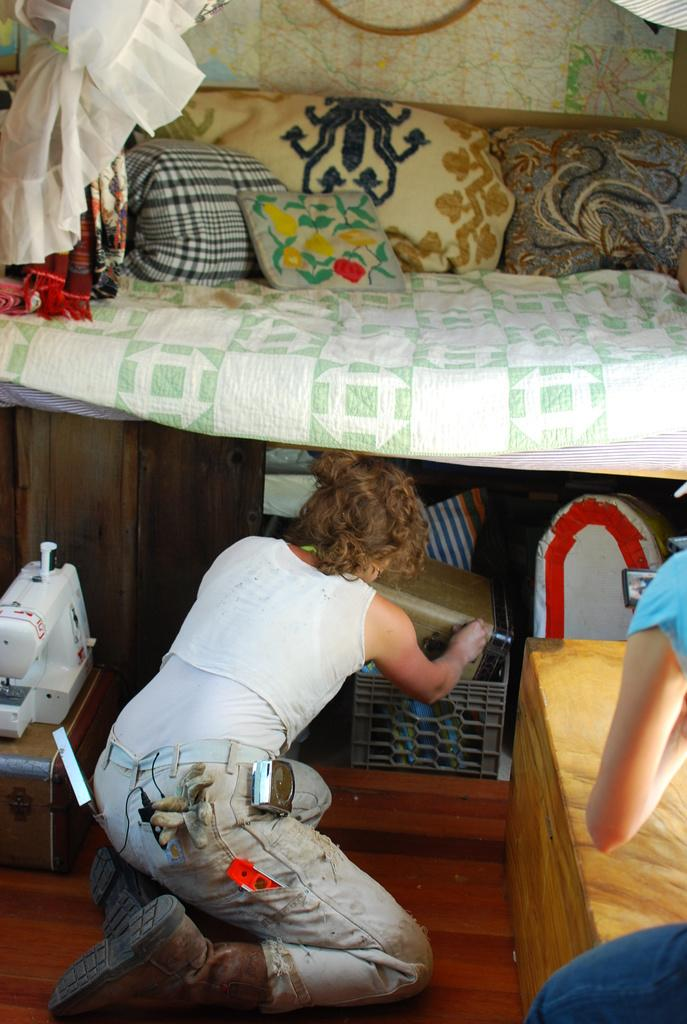How many people are present in the image? There are two people in the image. What is the surface beneath the people? There is a floor visible in the image. What type of material is used for some of the objects in the image? There are wooden objects in the image. What type of soft furnishings can be seen in the image? There are pillows in the image. What type of personal items are visible in the image? There are clothes in the image. Can you describe any unspecified objects in the image? There are unspecified objects in the image, but their details are not provided in the facts. What type of glove is the person wearing in the image? There is no mention of gloves or any type of hand covering in the image. Where can you find the market in the image? There is no mention of a market or any type of commercial establishment in the image. 